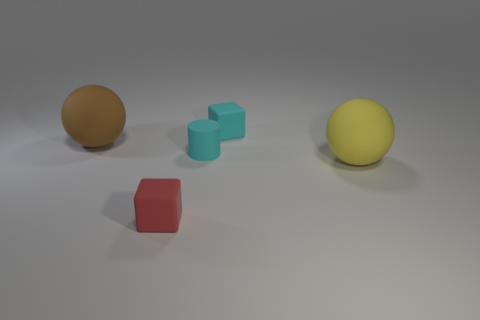What shape is the tiny object that is the same color as the tiny rubber cylinder?
Your answer should be compact. Cube. Are there any other things that are made of the same material as the tiny red thing?
Your answer should be compact. Yes. What is the shape of the thing on the right side of the rubber cube behind the tiny thing in front of the cyan cylinder?
Ensure brevity in your answer.  Sphere. Are there fewer rubber cylinders that are behind the big brown object than big matte objects that are to the right of the cyan cylinder?
Keep it short and to the point. Yes. There is a big matte thing left of the rubber ball that is on the right side of the cyan cube; what is its shape?
Make the answer very short. Sphere. What number of brown things are cubes or matte objects?
Your answer should be very brief. 1. Are there fewer spheres that are on the left side of the red block than yellow matte spheres?
Keep it short and to the point. No. What number of matte cubes are behind the tiny cube right of the small red matte cube?
Your response must be concise. 0. What number of other objects are there of the same size as the yellow thing?
Make the answer very short. 1. What number of things are big yellow things or rubber balls that are right of the big brown thing?
Your response must be concise. 1. 